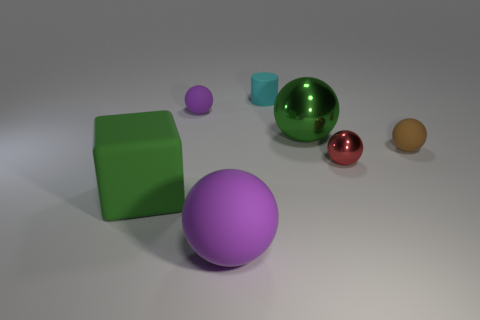Add 1 small purple rubber things. How many objects exist? 8 Subtract all green spheres. How many spheres are left? 4 Subtract all cubes. How many objects are left? 6 Subtract 1 cubes. How many cubes are left? 0 Subtract all red spheres. How many spheres are left? 4 Subtract 0 gray cubes. How many objects are left? 7 Subtract all gray balls. Subtract all purple cylinders. How many balls are left? 5 Subtract all cyan cylinders. How many purple spheres are left? 2 Subtract all large spheres. Subtract all gray matte cylinders. How many objects are left? 5 Add 5 tiny rubber cylinders. How many tiny rubber cylinders are left? 6 